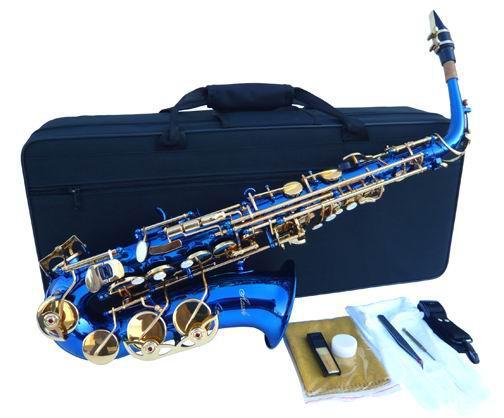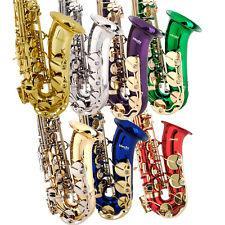The first image is the image on the left, the second image is the image on the right. For the images displayed, is the sentence "There are more instruments shown in the image on the left." factually correct? Answer yes or no. No. The first image is the image on the left, the second image is the image on the right. For the images displayed, is the sentence "An image shows just one view of one bright blue saxophone with brass-colored buttons." factually correct? Answer yes or no. Yes. 